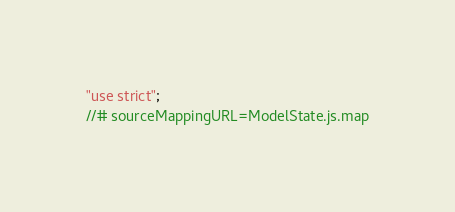Convert code to text. <code><loc_0><loc_0><loc_500><loc_500><_JavaScript_>"use strict";
//# sourceMappingURL=ModelState.js.map</code> 